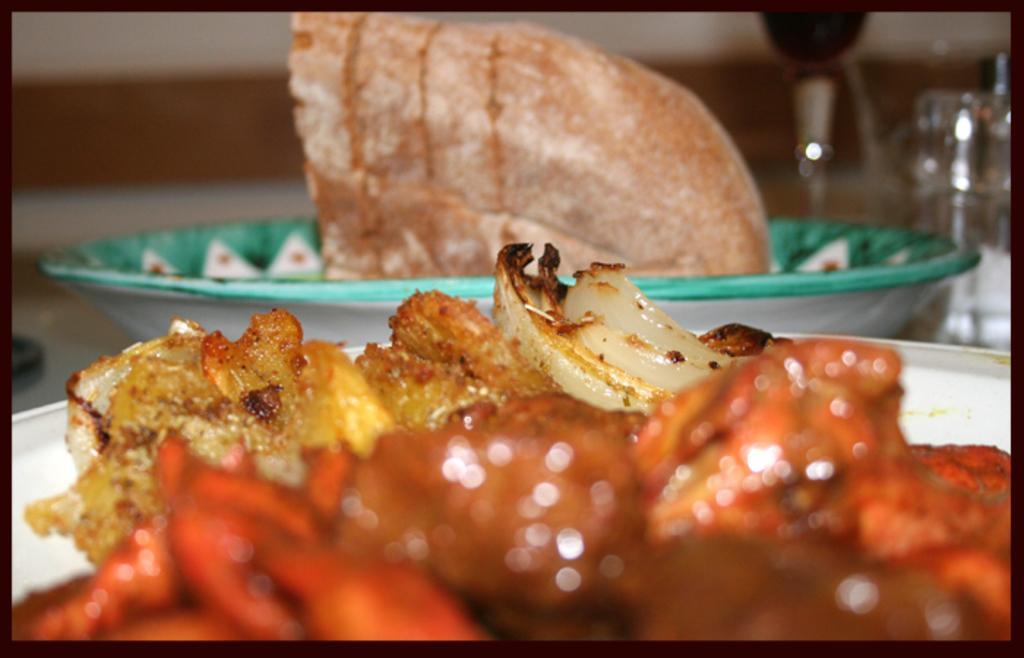In one or two sentences, can you explain what this image depicts? In this picture we can see food in the plates and we can see blurry background. 